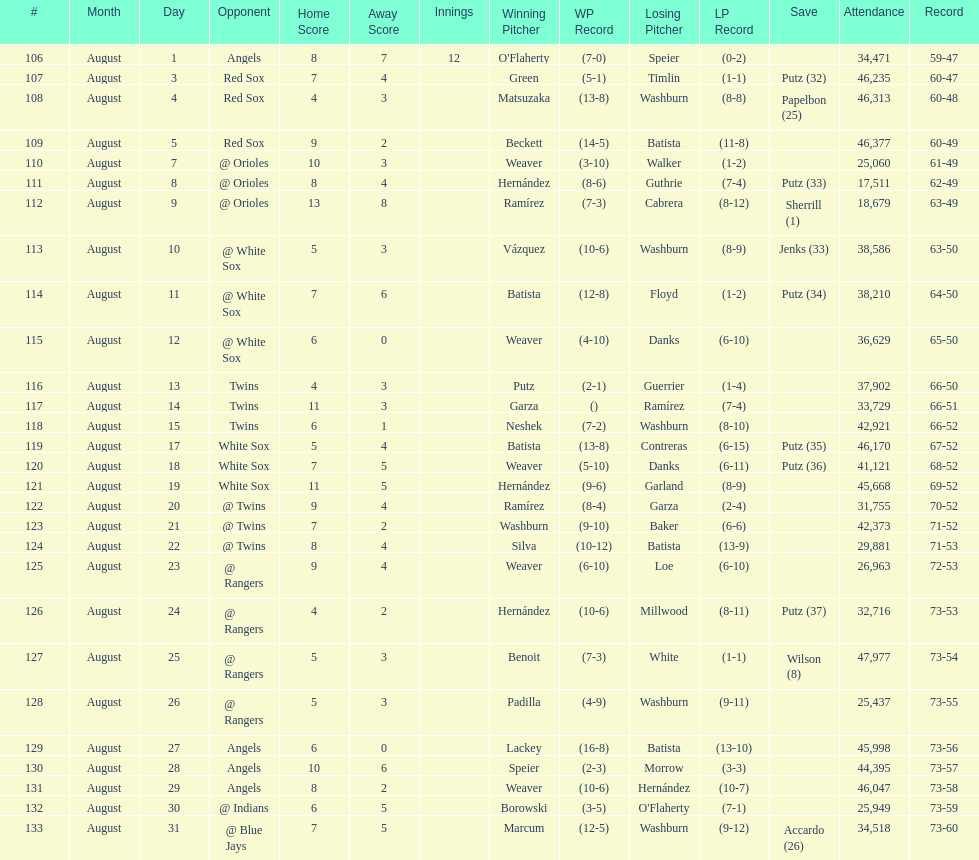Games above 30,000 in attendance 21. 